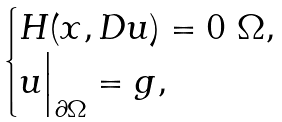<formula> <loc_0><loc_0><loc_500><loc_500>\begin{cases} H ( x , D u ) = 0 \ \Omega , \\ u \Big | _ { \partial \Omega } = g , \end{cases}</formula> 